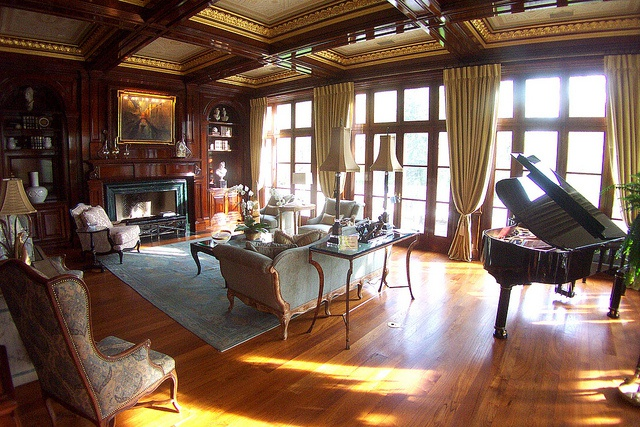Describe the objects in this image and their specific colors. I can see chair in black, maroon, and gray tones, couch in black, maroon, darkgray, and gray tones, chair in black, lightgray, maroon, and darkgray tones, potted plant in black, darkgreen, and gray tones, and chair in black, gray, darkgray, and white tones in this image. 